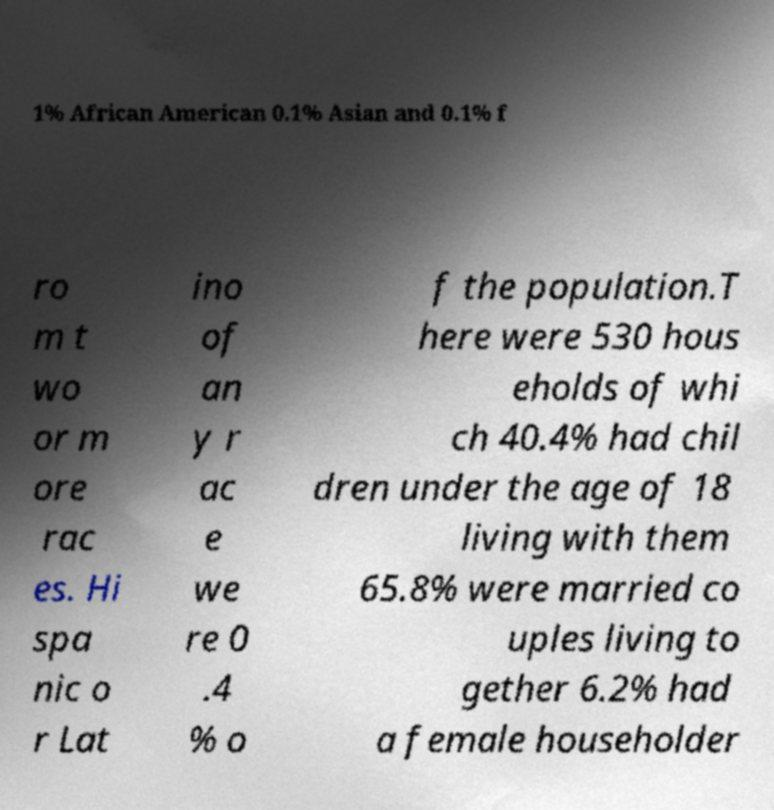Could you assist in decoding the text presented in this image and type it out clearly? 1% African American 0.1% Asian and 0.1% f ro m t wo or m ore rac es. Hi spa nic o r Lat ino of an y r ac e we re 0 .4 % o f the population.T here were 530 hous eholds of whi ch 40.4% had chil dren under the age of 18 living with them 65.8% were married co uples living to gether 6.2% had a female householder 